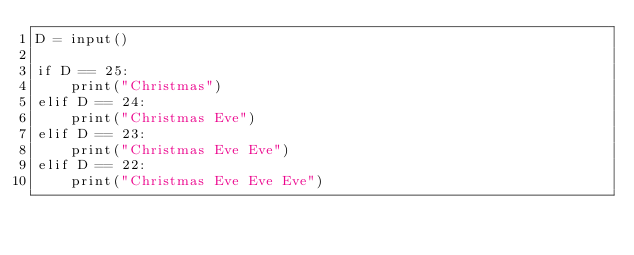<code> <loc_0><loc_0><loc_500><loc_500><_Python_>D = input()

if D == 25:
    print("Christmas")
elif D == 24:
    print("Christmas Eve")
elif D == 23:
    print("Christmas Eve Eve")
elif D == 22:
    print("Christmas Eve Eve Eve")
</code> 